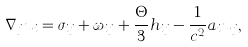<formula> <loc_0><loc_0><loc_500><loc_500>\nabla _ { j } u _ { i } = \sigma _ { i j } + \omega _ { i j } + \frac { \Theta } { 3 } h _ { i j } - \frac { 1 } { c ^ { 2 } } a _ { i } u _ { j } ,</formula> 